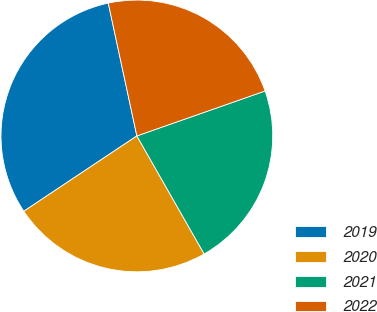<chart> <loc_0><loc_0><loc_500><loc_500><pie_chart><fcel>2019<fcel>2020<fcel>2021<fcel>2022<nl><fcel>30.98%<fcel>23.89%<fcel>22.12%<fcel>23.01%<nl></chart> 